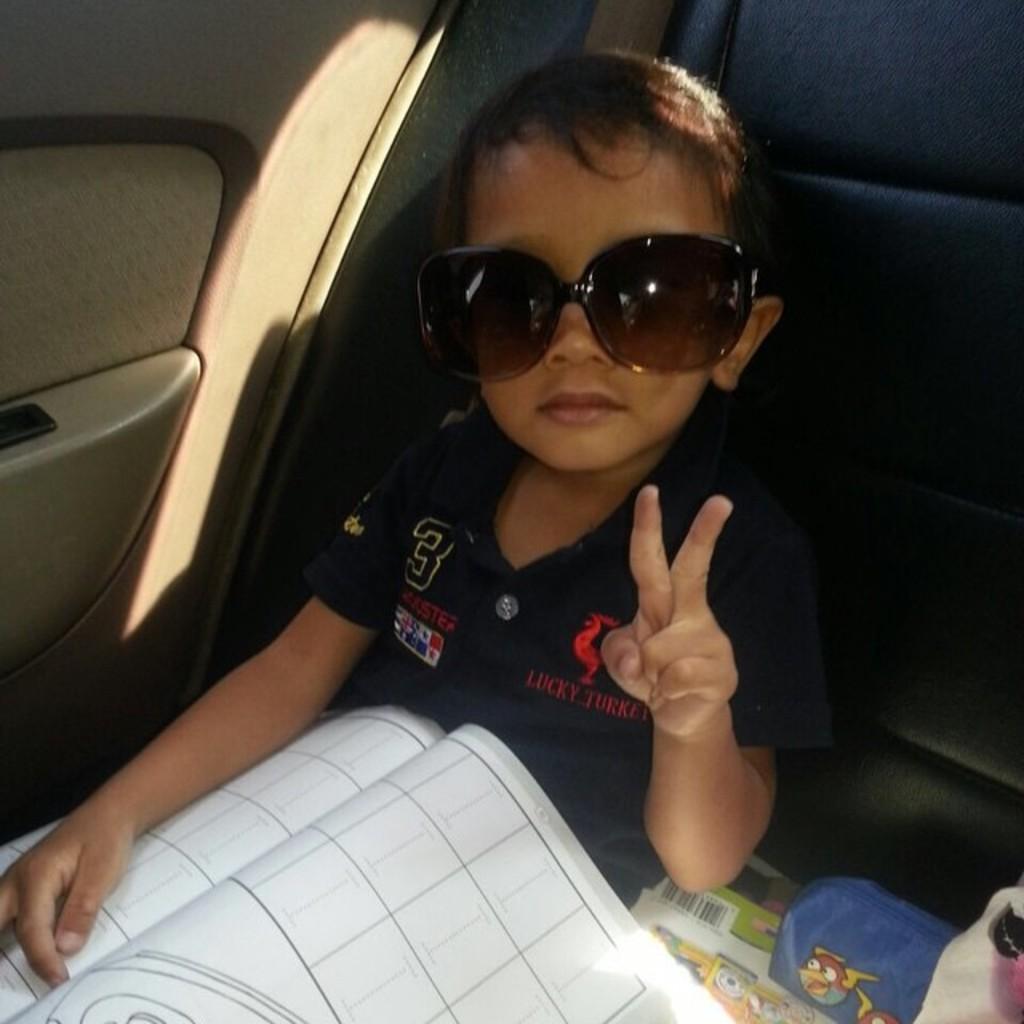Describe this image in one or two sentences. In this picture we can observe a boy sitting in the seat of a vehicle. There is a book in his lap. This boy is wearing spectacles. 